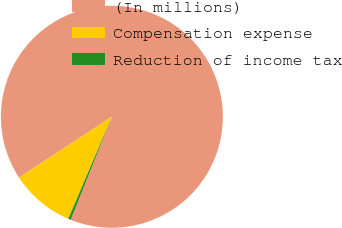Convert chart. <chart><loc_0><loc_0><loc_500><loc_500><pie_chart><fcel>(In millions)<fcel>Compensation expense<fcel>Reduction of income tax<nl><fcel>90.29%<fcel>9.35%<fcel>0.36%<nl></chart> 